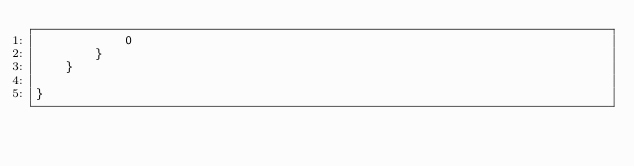<code> <loc_0><loc_0><loc_500><loc_500><_Kotlin_>            0
        }
    }

}</code> 